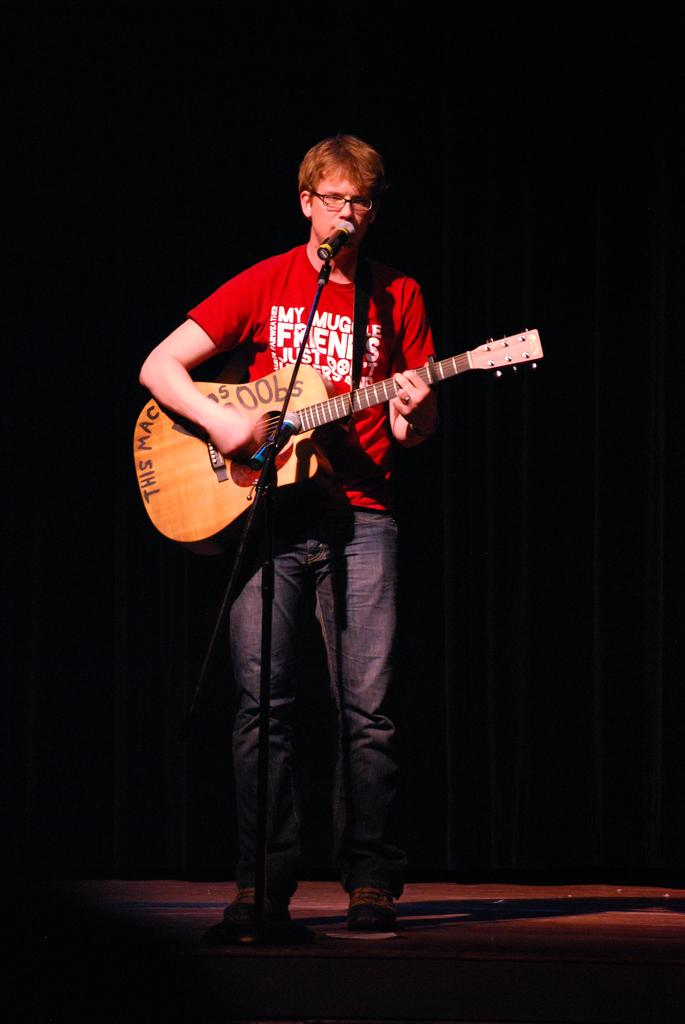What is the man in the image doing? The man is singing in the image. What is the man using to amplify his voice? The man is using a microphone in the image. What musical instrument is the man playing? The man is playing a guitar in the image. How many children are playing with the deer near the man in the image? There are no children or deer present in the image; it only features a man singing with a microphone and playing a guitar. 